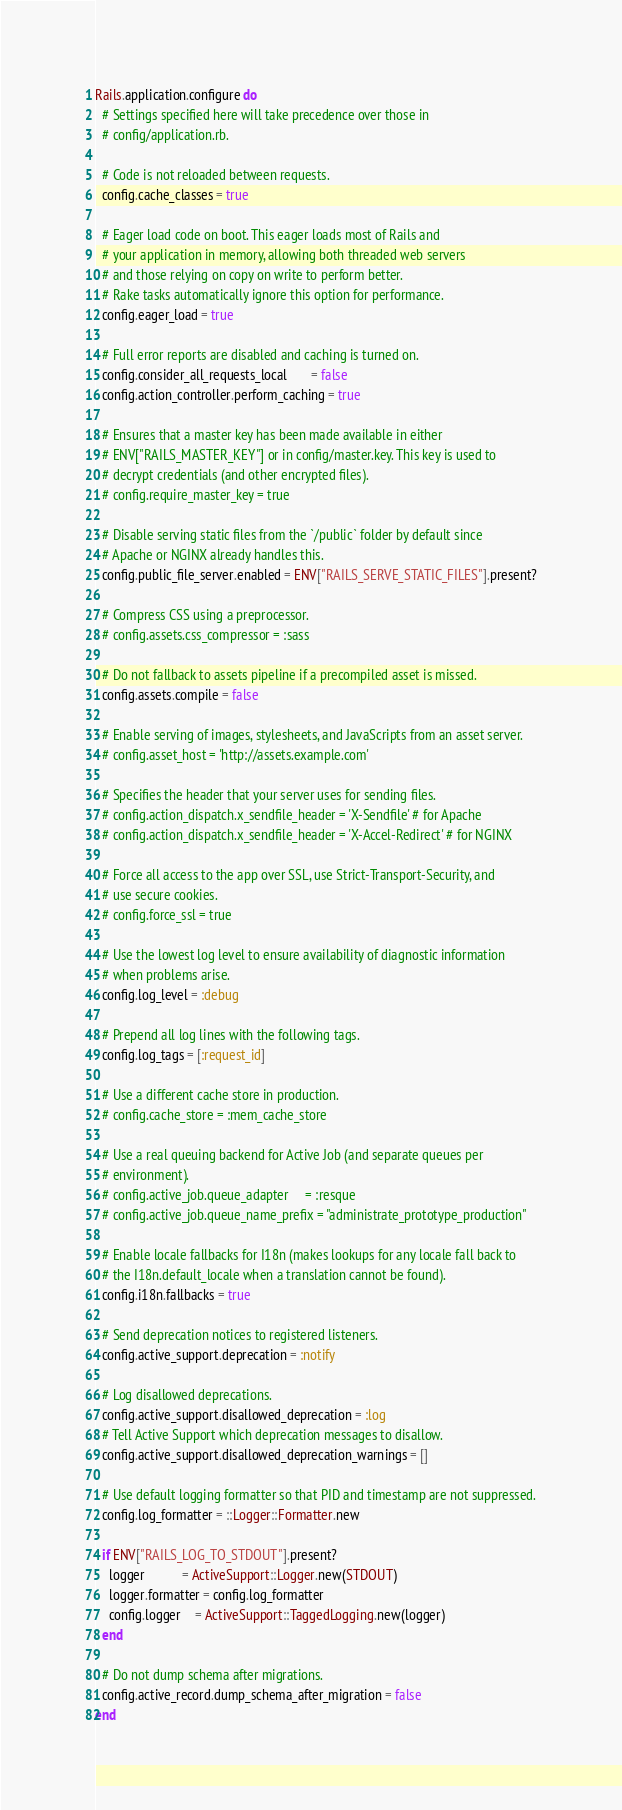<code> <loc_0><loc_0><loc_500><loc_500><_Ruby_>Rails.application.configure do
  # Settings specified here will take precedence over those in
  # config/application.rb.

  # Code is not reloaded between requests.
  config.cache_classes = true

  # Eager load code on boot. This eager loads most of Rails and
  # your application in memory, allowing both threaded web servers
  # and those relying on copy on write to perform better.
  # Rake tasks automatically ignore this option for performance.
  config.eager_load = true

  # Full error reports are disabled and caching is turned on.
  config.consider_all_requests_local       = false
  config.action_controller.perform_caching = true

  # Ensures that a master key has been made available in either
  # ENV["RAILS_MASTER_KEY"] or in config/master.key. This key is used to
  # decrypt credentials (and other encrypted files).
  # config.require_master_key = true

  # Disable serving static files from the `/public` folder by default since
  # Apache or NGINX already handles this.
  config.public_file_server.enabled = ENV["RAILS_SERVE_STATIC_FILES"].present?

  # Compress CSS using a preprocessor.
  # config.assets.css_compressor = :sass

  # Do not fallback to assets pipeline if a precompiled asset is missed.
  config.assets.compile = false

  # Enable serving of images, stylesheets, and JavaScripts from an asset server.
  # config.asset_host = 'http://assets.example.com'

  # Specifies the header that your server uses for sending files.
  # config.action_dispatch.x_sendfile_header = 'X-Sendfile' # for Apache
  # config.action_dispatch.x_sendfile_header = 'X-Accel-Redirect' # for NGINX

  # Force all access to the app over SSL, use Strict-Transport-Security, and
  # use secure cookies.
  # config.force_ssl = true

  # Use the lowest log level to ensure availability of diagnostic information
  # when problems arise.
  config.log_level = :debug

  # Prepend all log lines with the following tags.
  config.log_tags = [:request_id]

  # Use a different cache store in production.
  # config.cache_store = :mem_cache_store

  # Use a real queuing backend for Active Job (and separate queues per
  # environment).
  # config.active_job.queue_adapter     = :resque
  # config.active_job.queue_name_prefix = "administrate_prototype_production"

  # Enable locale fallbacks for I18n (makes lookups for any locale fall back to
  # the I18n.default_locale when a translation cannot be found).
  config.i18n.fallbacks = true

  # Send deprecation notices to registered listeners.
  config.active_support.deprecation = :notify

  # Log disallowed deprecations.
  config.active_support.disallowed_deprecation = :log
  # Tell Active Support which deprecation messages to disallow.
  config.active_support.disallowed_deprecation_warnings = []

  # Use default logging formatter so that PID and timestamp are not suppressed.
  config.log_formatter = ::Logger::Formatter.new

  if ENV["RAILS_LOG_TO_STDOUT"].present?
    logger           = ActiveSupport::Logger.new(STDOUT)
    logger.formatter = config.log_formatter
    config.logger    = ActiveSupport::TaggedLogging.new(logger)
  end

  # Do not dump schema after migrations.
  config.active_record.dump_schema_after_migration = false
end
</code> 